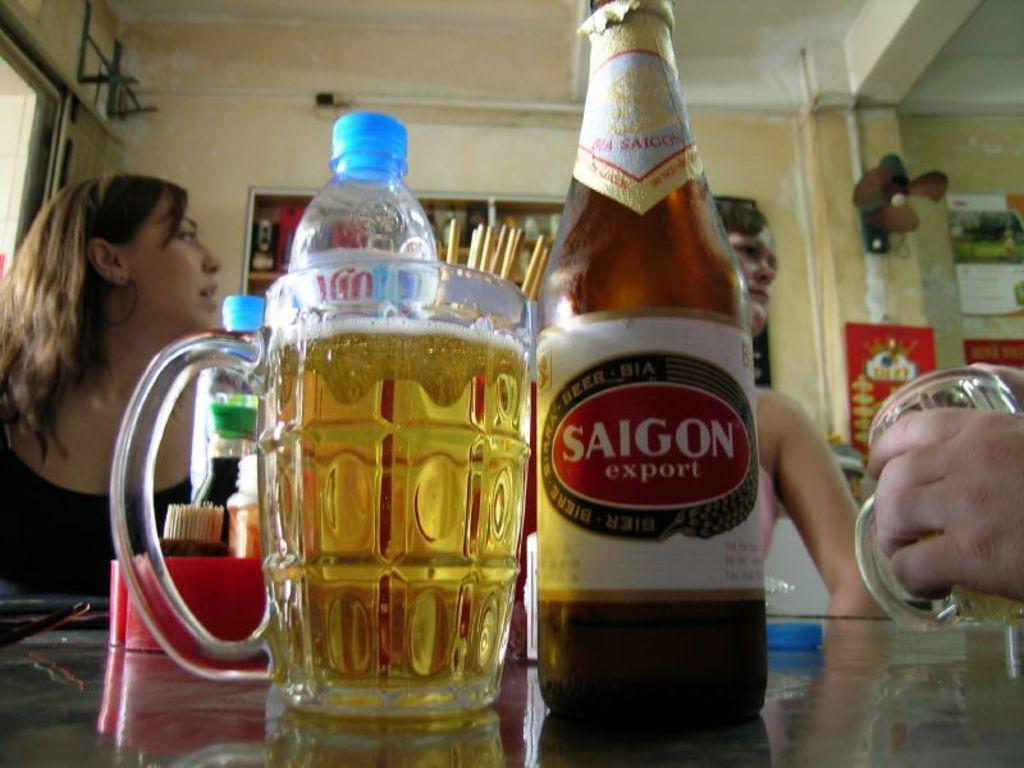In one or two sentences, can you explain what this image depicts? It's a jug and a beer bottle behind this there are two girls sitting 